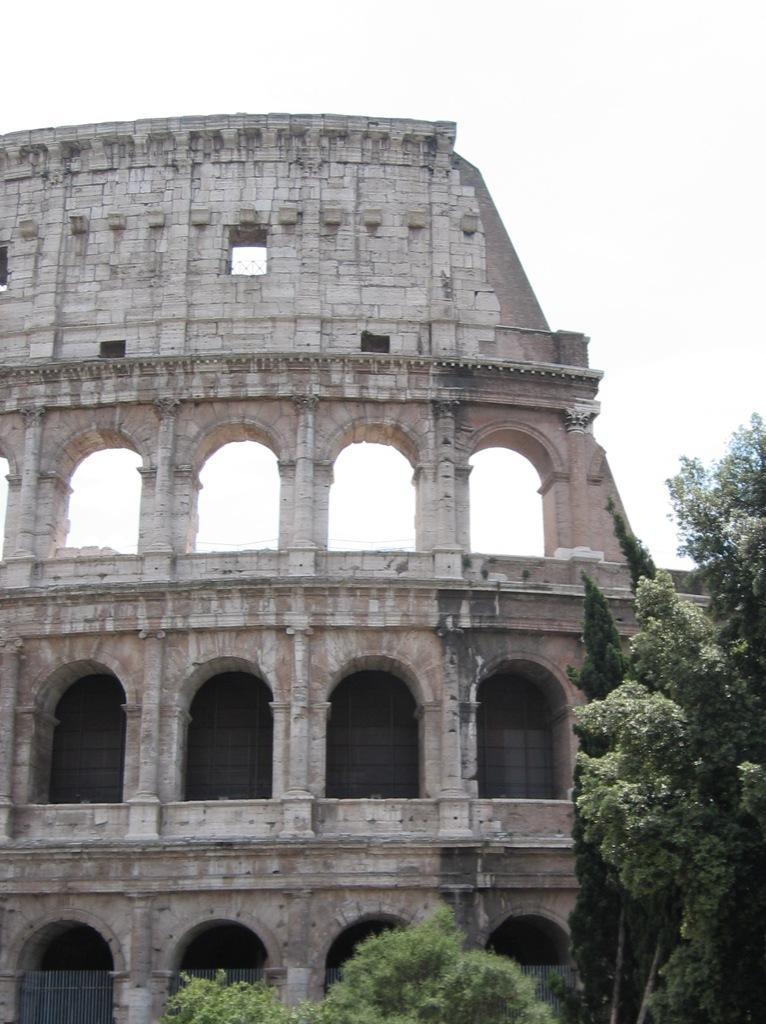What type of structure is depicted in the image? The image appears to depict an ancient monument, specifically the Colosseum. What can be seen in the background of the image? There are trees with branches and leaves in the image. Is there any barrier or enclosure visible in the image? Yes, there is a fence in the image. What type of soap is the farmer using to clean the card in the image? There is no farmer, soap, or card present in the image. 